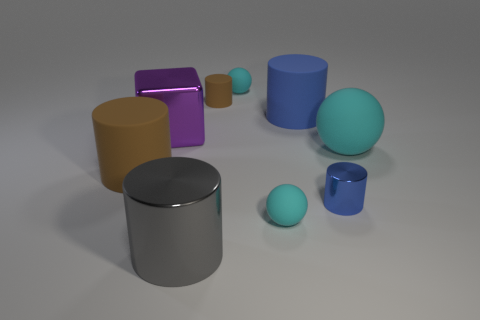Are there an equal number of big purple metal blocks that are to the left of the tiny blue metal object and gray cylinders that are behind the small brown matte object?
Provide a succinct answer. No. There is a brown matte object that is to the right of the large metal thing that is behind the gray cylinder; how many large cylinders are to the left of it?
Your answer should be very brief. 2. Is the color of the small metal thing the same as the large matte cylinder that is right of the small matte cylinder?
Provide a succinct answer. Yes. There is a cube that is made of the same material as the large gray cylinder; what size is it?
Ensure brevity in your answer.  Large. Is the number of large shiny objects that are in front of the metallic cube greater than the number of brown rubber cubes?
Offer a very short reply. Yes. What material is the sphere behind the blue cylinder that is behind the brown cylinder that is to the left of the small matte cylinder?
Ensure brevity in your answer.  Rubber. Is the big blue object made of the same material as the brown thing in front of the large cube?
Offer a very short reply. Yes. What is the material of the gray object that is the same shape as the small brown thing?
Your answer should be compact. Metal. Are there more big metallic cylinders that are right of the large sphere than cyan rubber objects left of the large purple object?
Your response must be concise. No. There is a gray thing that is made of the same material as the big purple block; what shape is it?
Your answer should be compact. Cylinder. 